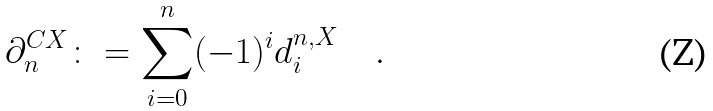<formula> <loc_0><loc_0><loc_500><loc_500>\partial ^ { C X } _ { n } \colon = \sum _ { i = 0 } ^ { n } ( - 1 ) ^ { i } d ^ { n , X } _ { i } \quad .</formula> 